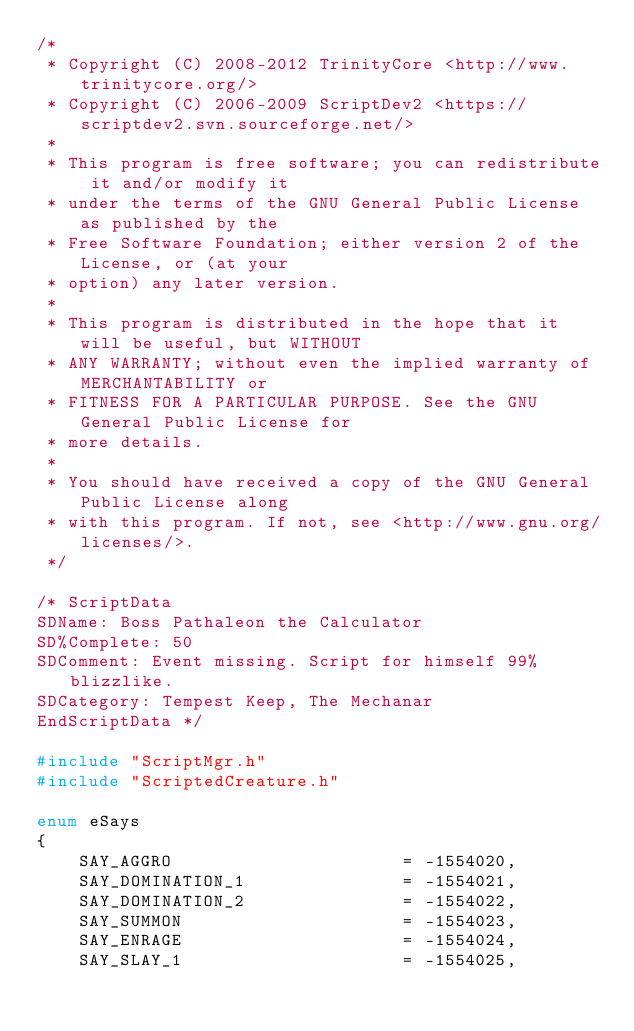<code> <loc_0><loc_0><loc_500><loc_500><_C++_>/*
 * Copyright (C) 2008-2012 TrinityCore <http://www.trinitycore.org/>
 * Copyright (C) 2006-2009 ScriptDev2 <https://scriptdev2.svn.sourceforge.net/>
 *
 * This program is free software; you can redistribute it and/or modify it
 * under the terms of the GNU General Public License as published by the
 * Free Software Foundation; either version 2 of the License, or (at your
 * option) any later version.
 *
 * This program is distributed in the hope that it will be useful, but WITHOUT
 * ANY WARRANTY; without even the implied warranty of MERCHANTABILITY or
 * FITNESS FOR A PARTICULAR PURPOSE. See the GNU General Public License for
 * more details.
 *
 * You should have received a copy of the GNU General Public License along
 * with this program. If not, see <http://www.gnu.org/licenses/>.
 */

/* ScriptData
SDName: Boss Pathaleon the Calculator
SD%Complete: 50
SDComment: Event missing. Script for himself 99% blizzlike.
SDCategory: Tempest Keep, The Mechanar
EndScriptData */

#include "ScriptMgr.h"
#include "ScriptedCreature.h"

enum eSays
{
    SAY_AGGRO                      = -1554020,
    SAY_DOMINATION_1               = -1554021,
    SAY_DOMINATION_2               = -1554022,
    SAY_SUMMON                     = -1554023,
    SAY_ENRAGE                     = -1554024,
    SAY_SLAY_1                     = -1554025,</code> 